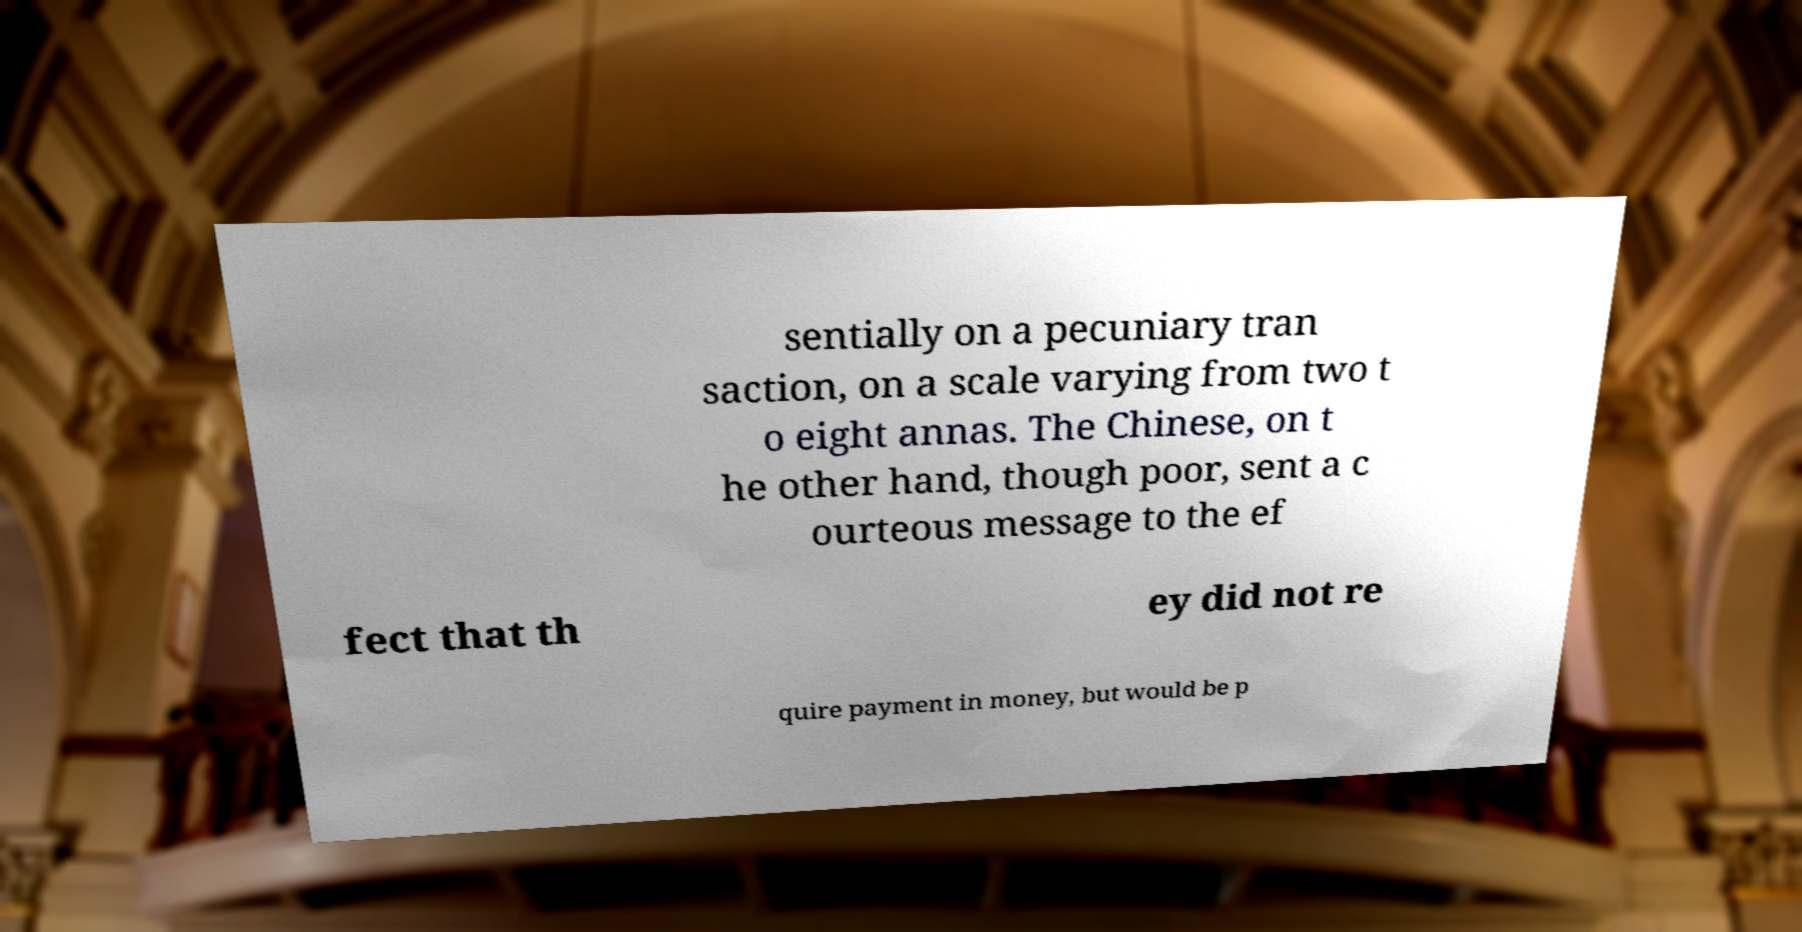Can you accurately transcribe the text from the provided image for me? sentially on a pecuniary tran saction, on a scale varying from two t o eight annas. The Chinese, on t he other hand, though poor, sent a c ourteous message to the ef fect that th ey did not re quire payment in money, but would be p 